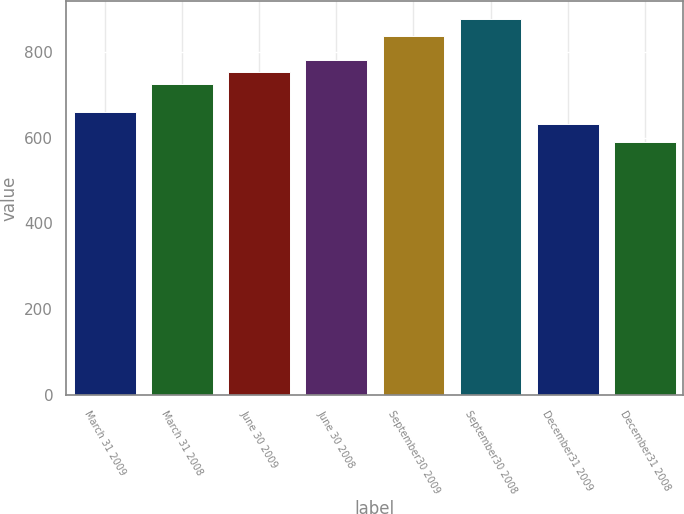Convert chart. <chart><loc_0><loc_0><loc_500><loc_500><bar_chart><fcel>March 31 2009<fcel>March 31 2008<fcel>June 30 2009<fcel>June 30 2008<fcel>September30 2009<fcel>September30 2008<fcel>December31 2009<fcel>December31 2008<nl><fcel>659.5<fcel>724<fcel>752.5<fcel>781<fcel>836<fcel>875<fcel>631<fcel>590<nl></chart> 